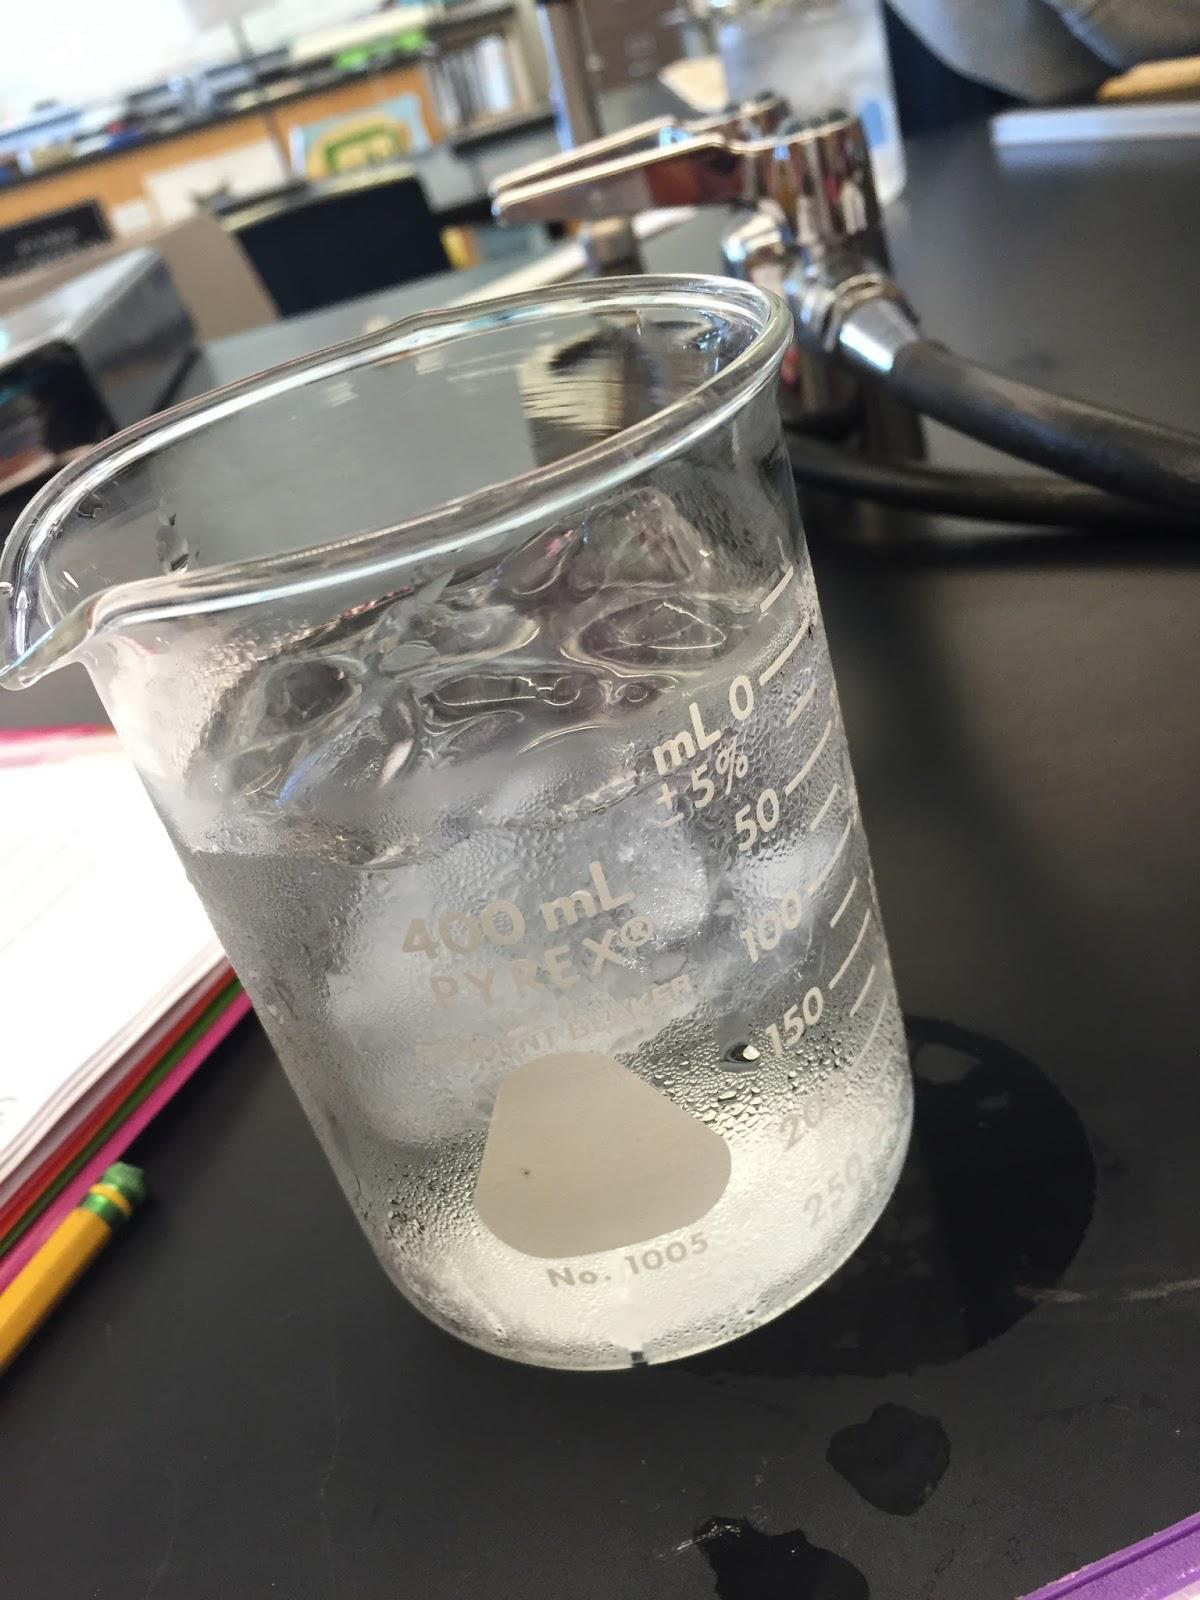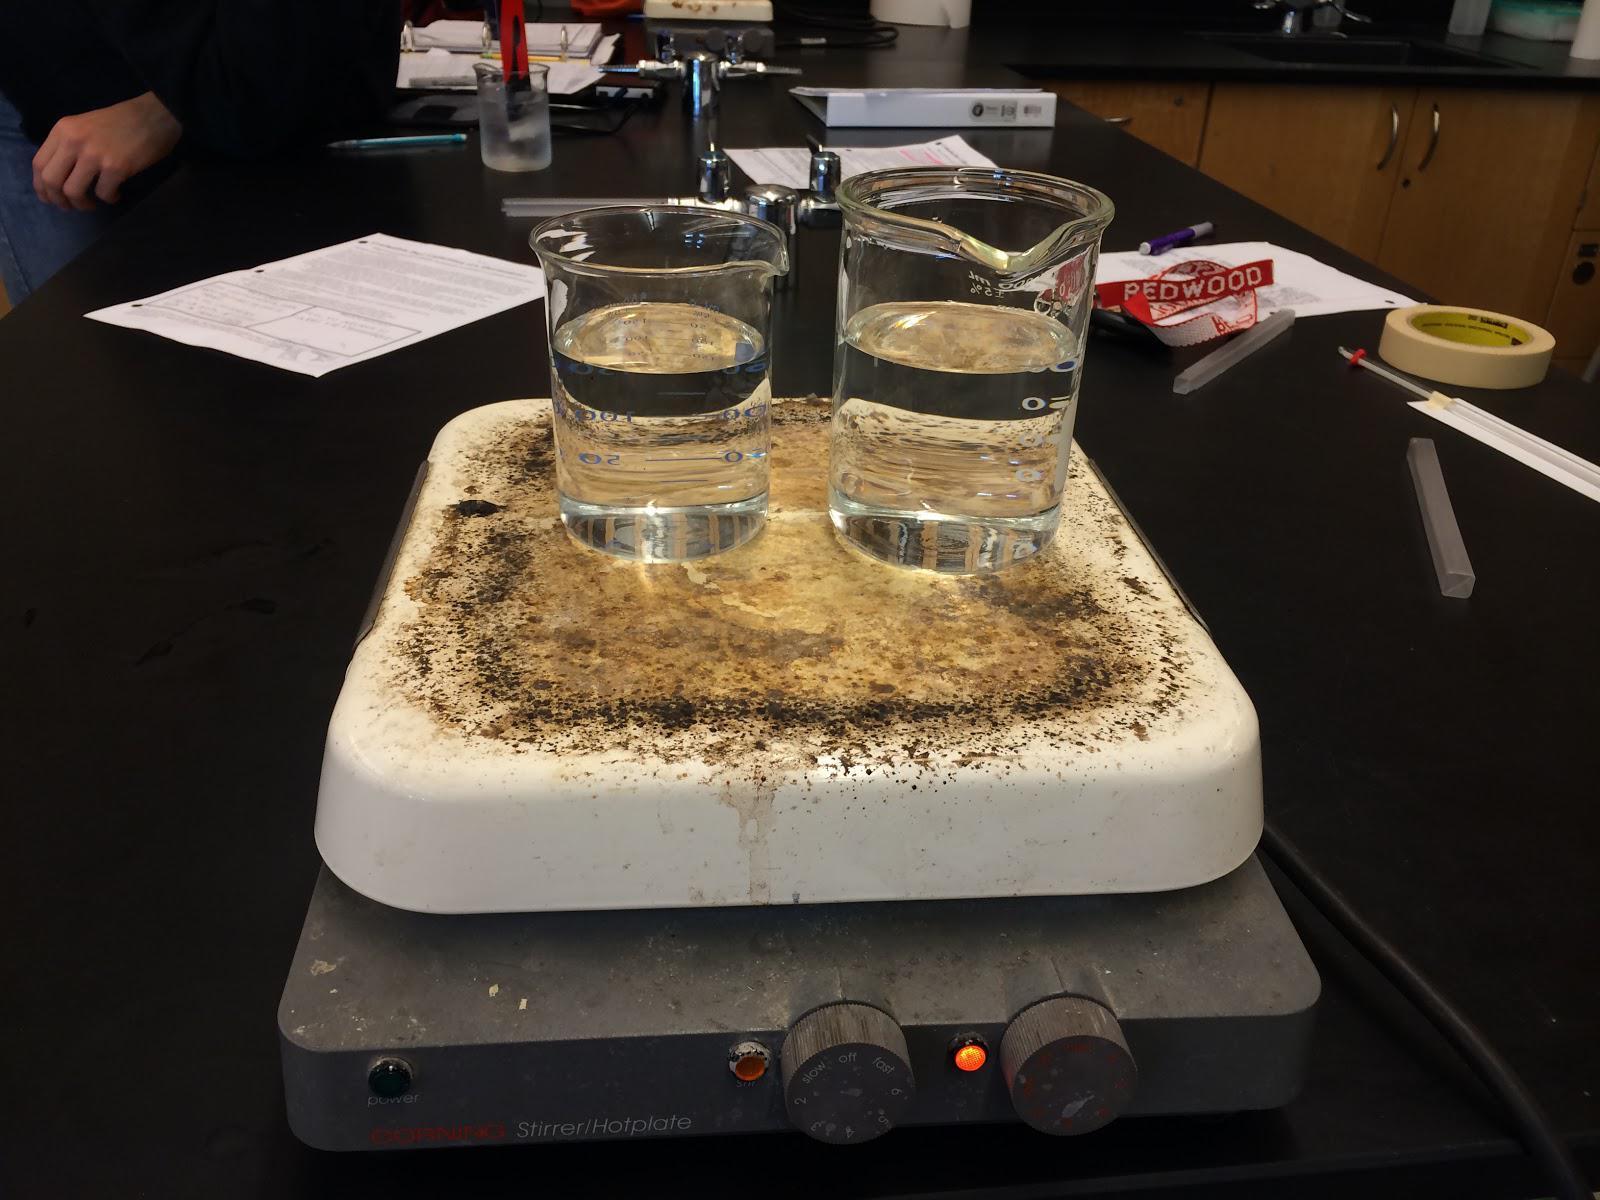The first image is the image on the left, the second image is the image on the right. For the images displayed, is the sentence "At least three cylindrical beakers hold a clear liquid." factually correct? Answer yes or no. Yes. The first image is the image on the left, the second image is the image on the right. Examine the images to the left and right. Is the description "There appear to be exactly three containers visible." accurate? Answer yes or no. Yes. 